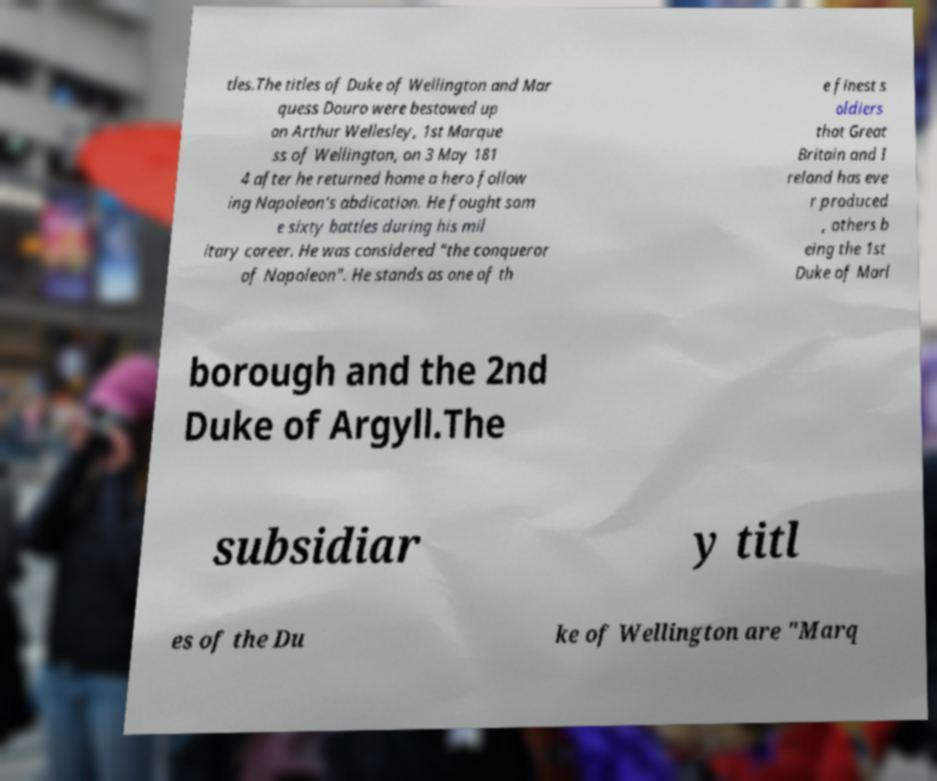Can you read and provide the text displayed in the image?This photo seems to have some interesting text. Can you extract and type it out for me? tles.The titles of Duke of Wellington and Mar quess Douro were bestowed up on Arthur Wellesley, 1st Marque ss of Wellington, on 3 May 181 4 after he returned home a hero follow ing Napoleon's abdication. He fought som e sixty battles during his mil itary career. He was considered "the conqueror of Napoleon". He stands as one of th e finest s oldiers that Great Britain and I reland has eve r produced , others b eing the 1st Duke of Marl borough and the 2nd Duke of Argyll.The subsidiar y titl es of the Du ke of Wellington are "Marq 